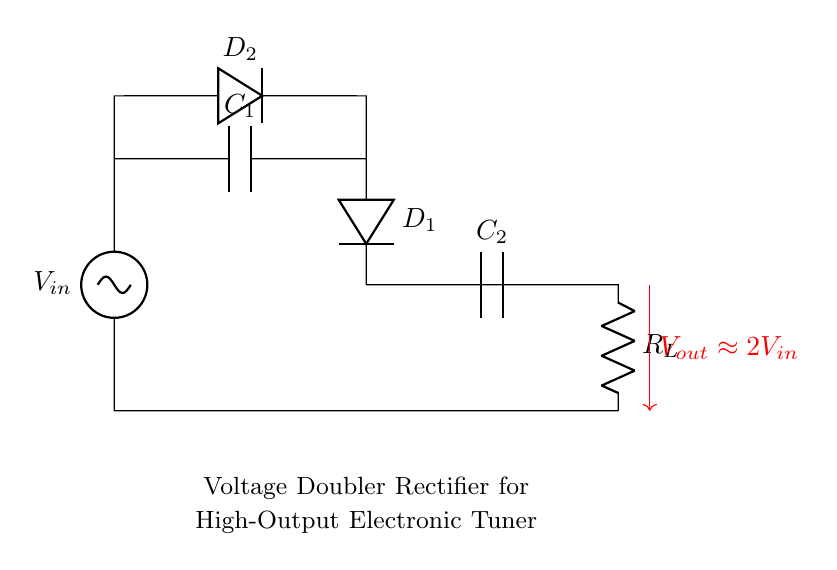What is the input voltage labeled? The input voltage is labeled as V_in, which indicates the voltage supplied to the circuit.
Answer: V_in What type of capacitors are used in this circuit? The components labeled as C_1 and C_2 are capacitors, which store electric charge in the circuit.
Answer: Capacitors How many diodes are present in this rectifier circuit? The circuit includes two diodes, D_1 and D_2, which are responsible for controlling the direction of current flow.
Answer: Two What is the output voltage approximately equal to? The output voltage is labeled as V_out and is described in the diagram as being approximately equal to 2 times the input voltage.
Answer: 2V_in What component provides the load to the circuit? The component labeled R_L indicates a resistor, which typically acts as a load in the circuit by dissipating the output voltage.
Answer: Resistor What happens to the voltage as it passes through this rectifier? This voltage doubler rectifier circuit doubles the input voltage due to its configuration, which can be understood by analyzing the role of the diodes and capacitors in charging and discharging.
Answer: Doubles voltage What is the purpose of the capacitors in this diagram? The capacitors, C_1 and C_2, are used for filtering and storing energy, smoothing out the output voltage, and aiding in the voltage doubling process when charged by the diodes.
Answer: Energy storage 